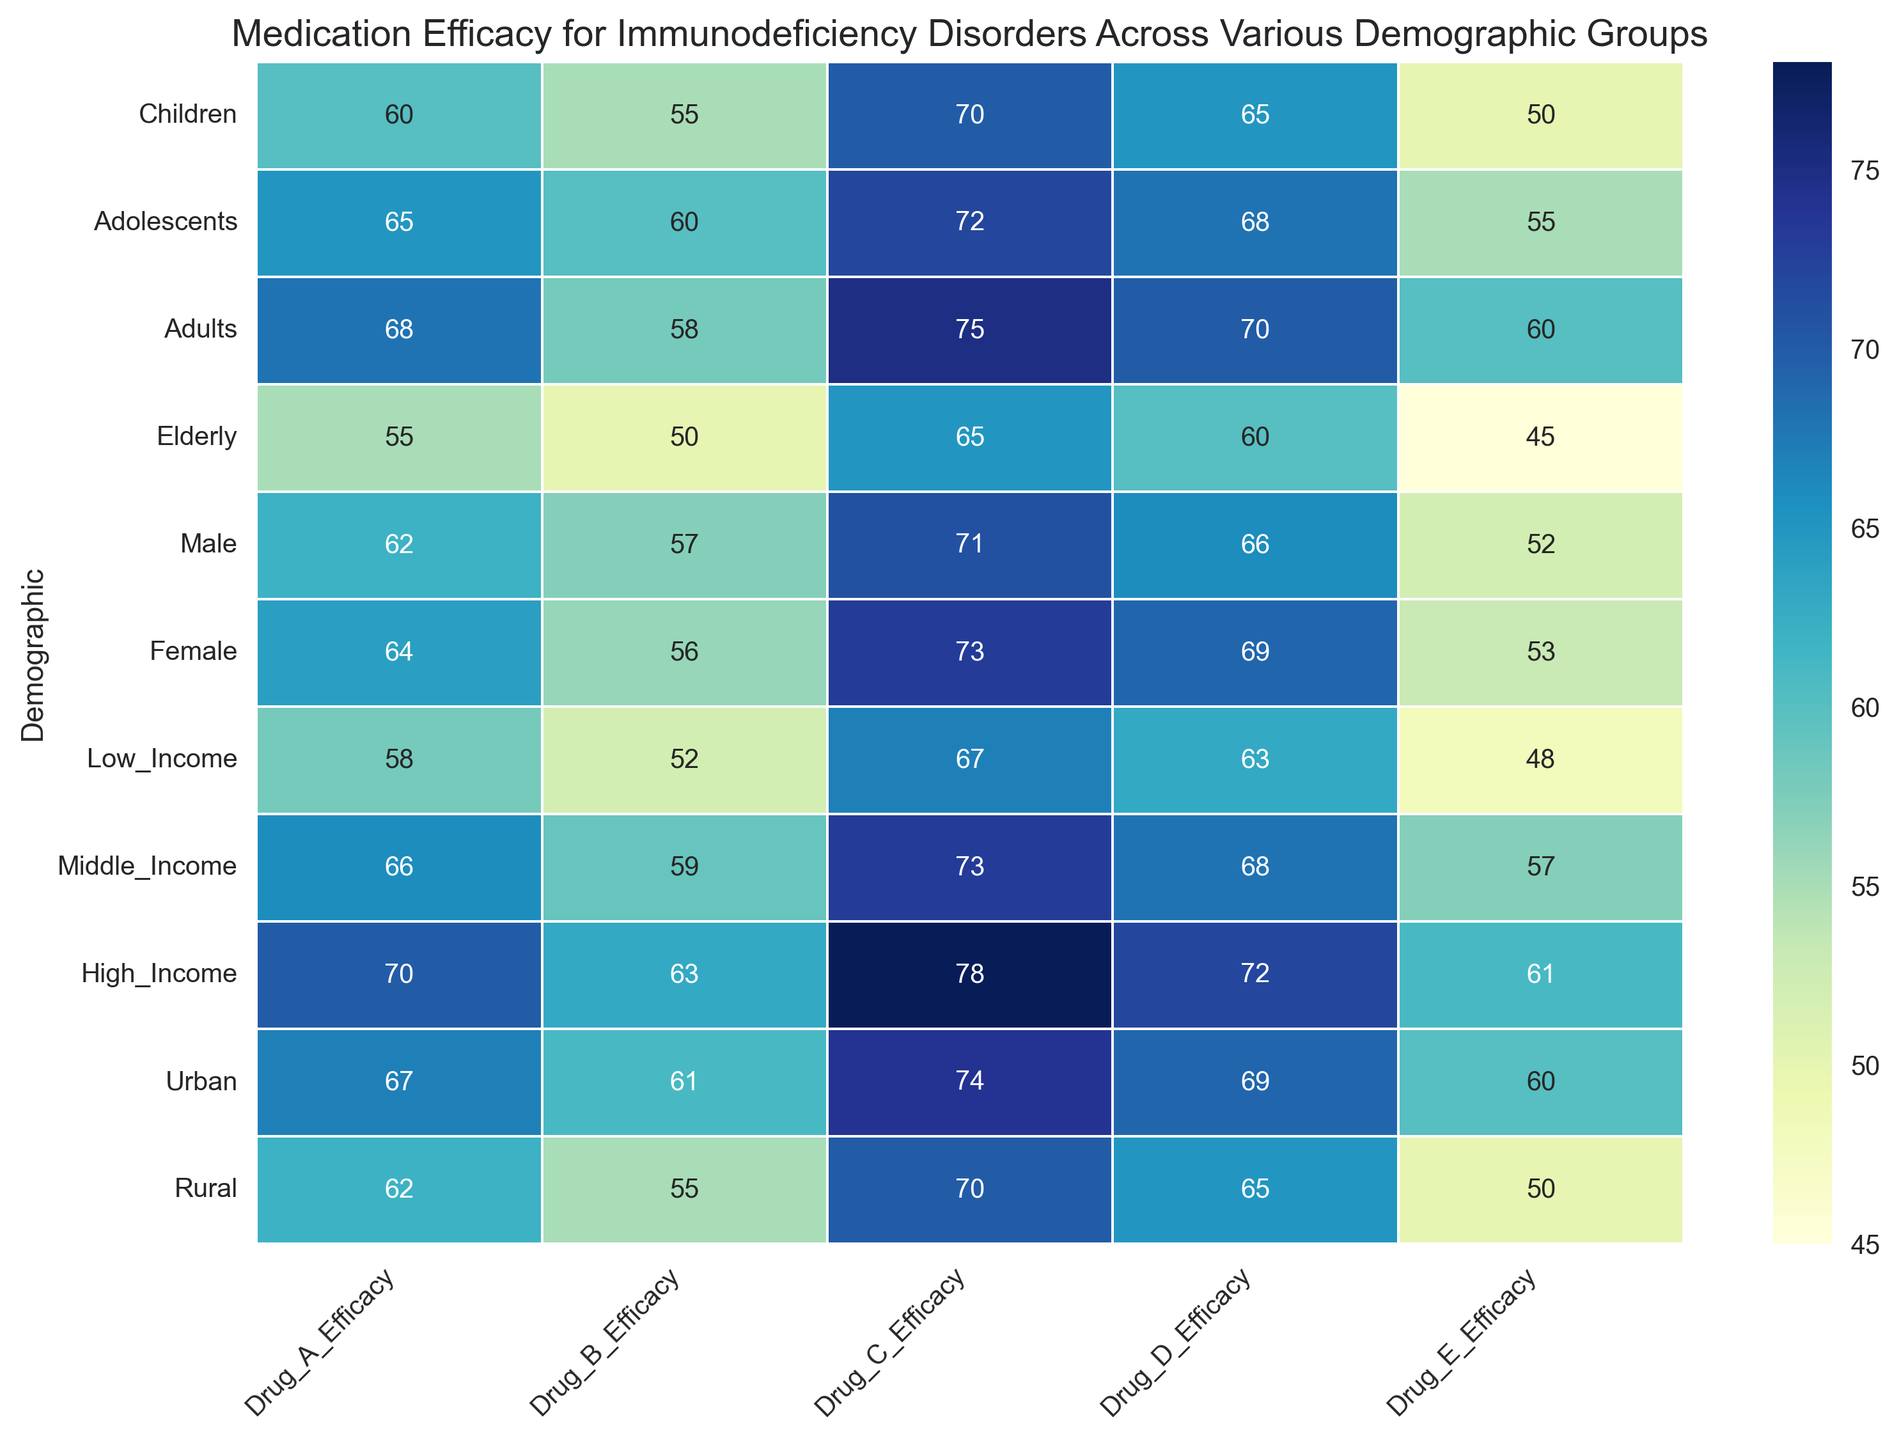Which demographic group has the highest efficacy for Drug A? By visual inspection, the darkest cell in the Drug A column indicates the highest efficacy. The demographic group associated with this cell is High Income.
Answer: High Income How does the efficacy of Drug C for Adolescents compare to that for Elderly? According to the heatmap, the efficacy of Drug C for Adolescents is higher. Adolescents have a value of 72 while Elderly have a value of 65 in Drug C.
Answer: Adolescents have higher efficacy Which demographic groups have similar efficacy values for Drug D? By comparing the shades in the Drug D column, Children and Rural have the same efficacy value (65). This can be confirmed by the annotations.
Answer: Children and Rural What is the average efficacy of Drug E for Male and Female groups? Male has efficacy 52, and Female has efficacy 53. Summing these (52 + 53) and dividing by 2 gives the average value, which is (52 + 53) / 2 = 52.5.
Answer: 52.5 What is the range of efficacy values for Drug B? Drug B values are: 55, 60, 58, 50, 57, 56, 52, 59, 63, 61, 55. The range is calculated as the difference between the maximum and minimum values, which is 63 - 50 = 13.
Answer: 13 Which drug has the highest efficacy for Adults? By looking at the Adults row, the highest value is 75, which corresponds to Drug C.
Answer: Drug C Does income level influence the efficacy of Drug E? Observing the Low, Middle, and High Income groups, the efficacy values increase as income level increases (48, 57, 61 respectively).
Answer: Yes What visual trend can be observed for Drug D across different demographic groups? The shading of cells for Drug D generally gets darker from Children to High Income, indicating increasing efficacy values.
Answer: Increasing efficacy from Children to High Income Identify the demographic group with the lowest efficacy for any drug. Which drug and value are these? By looking at the lightest cells across the entire heatmap, the Elderly group and Drug E combination stands out with the value 45.
Answer: Elderly, Drug E, 45 